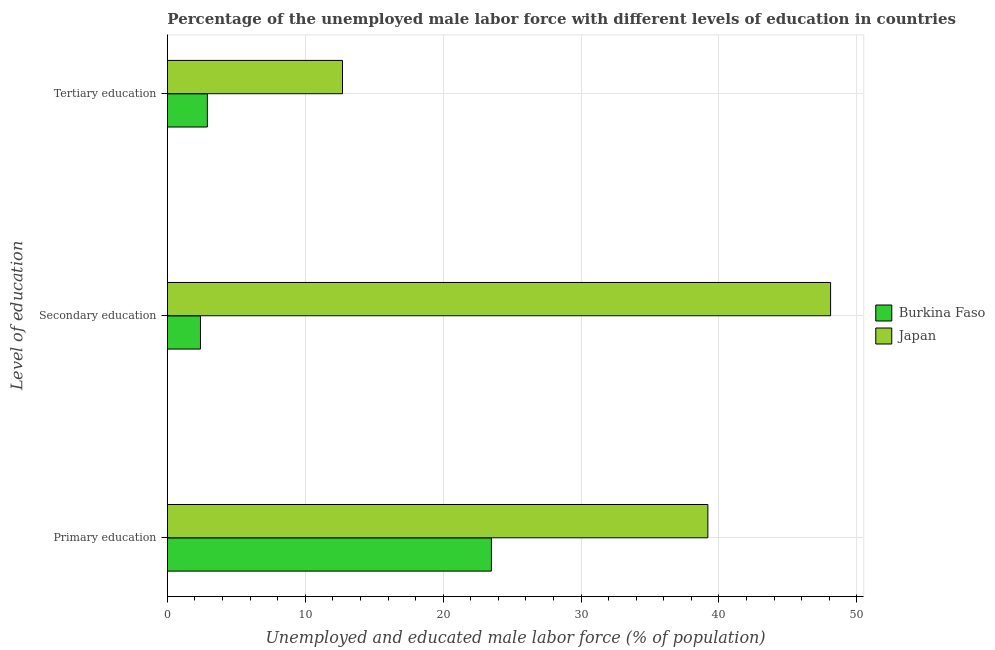Are the number of bars per tick equal to the number of legend labels?
Your answer should be compact. Yes. How many bars are there on the 1st tick from the bottom?
Offer a very short reply. 2. What is the label of the 2nd group of bars from the top?
Offer a terse response. Secondary education. What is the percentage of male labor force who received secondary education in Burkina Faso?
Make the answer very short. 2.4. Across all countries, what is the maximum percentage of male labor force who received primary education?
Offer a terse response. 39.2. Across all countries, what is the minimum percentage of male labor force who received secondary education?
Your response must be concise. 2.4. In which country was the percentage of male labor force who received secondary education maximum?
Give a very brief answer. Japan. In which country was the percentage of male labor force who received tertiary education minimum?
Provide a succinct answer. Burkina Faso. What is the total percentage of male labor force who received primary education in the graph?
Make the answer very short. 62.7. What is the difference between the percentage of male labor force who received primary education in Japan and that in Burkina Faso?
Your answer should be compact. 15.7. What is the difference between the percentage of male labor force who received primary education in Japan and the percentage of male labor force who received tertiary education in Burkina Faso?
Provide a succinct answer. 36.3. What is the average percentage of male labor force who received secondary education per country?
Keep it short and to the point. 25.25. What is the difference between the percentage of male labor force who received tertiary education and percentage of male labor force who received secondary education in Japan?
Your answer should be compact. -35.4. In how many countries, is the percentage of male labor force who received tertiary education greater than 2 %?
Make the answer very short. 2. What is the ratio of the percentage of male labor force who received tertiary education in Burkina Faso to that in Japan?
Offer a very short reply. 0.23. What is the difference between the highest and the second highest percentage of male labor force who received secondary education?
Give a very brief answer. 45.7. What is the difference between the highest and the lowest percentage of male labor force who received secondary education?
Offer a very short reply. 45.7. In how many countries, is the percentage of male labor force who received primary education greater than the average percentage of male labor force who received primary education taken over all countries?
Provide a short and direct response. 1. Is the sum of the percentage of male labor force who received tertiary education in Burkina Faso and Japan greater than the maximum percentage of male labor force who received secondary education across all countries?
Make the answer very short. No. What does the 2nd bar from the top in Primary education represents?
Make the answer very short. Burkina Faso. What does the 1st bar from the bottom in Secondary education represents?
Offer a terse response. Burkina Faso. How many bars are there?
Provide a short and direct response. 6. How many countries are there in the graph?
Your answer should be very brief. 2. What is the difference between two consecutive major ticks on the X-axis?
Your answer should be very brief. 10. Are the values on the major ticks of X-axis written in scientific E-notation?
Offer a very short reply. No. Does the graph contain any zero values?
Provide a short and direct response. No. Does the graph contain grids?
Offer a very short reply. Yes. Where does the legend appear in the graph?
Your answer should be compact. Center right. How are the legend labels stacked?
Your answer should be very brief. Vertical. What is the title of the graph?
Make the answer very short. Percentage of the unemployed male labor force with different levels of education in countries. What is the label or title of the X-axis?
Make the answer very short. Unemployed and educated male labor force (% of population). What is the label or title of the Y-axis?
Offer a terse response. Level of education. What is the Unemployed and educated male labor force (% of population) of Japan in Primary education?
Offer a terse response. 39.2. What is the Unemployed and educated male labor force (% of population) of Burkina Faso in Secondary education?
Give a very brief answer. 2.4. What is the Unemployed and educated male labor force (% of population) in Japan in Secondary education?
Give a very brief answer. 48.1. What is the Unemployed and educated male labor force (% of population) of Burkina Faso in Tertiary education?
Your answer should be compact. 2.9. What is the Unemployed and educated male labor force (% of population) of Japan in Tertiary education?
Provide a succinct answer. 12.7. Across all Level of education, what is the maximum Unemployed and educated male labor force (% of population) in Burkina Faso?
Provide a succinct answer. 23.5. Across all Level of education, what is the maximum Unemployed and educated male labor force (% of population) in Japan?
Give a very brief answer. 48.1. Across all Level of education, what is the minimum Unemployed and educated male labor force (% of population) of Burkina Faso?
Your response must be concise. 2.4. Across all Level of education, what is the minimum Unemployed and educated male labor force (% of population) in Japan?
Offer a terse response. 12.7. What is the total Unemployed and educated male labor force (% of population) in Burkina Faso in the graph?
Your response must be concise. 28.8. What is the difference between the Unemployed and educated male labor force (% of population) of Burkina Faso in Primary education and that in Secondary education?
Provide a succinct answer. 21.1. What is the difference between the Unemployed and educated male labor force (% of population) of Japan in Primary education and that in Secondary education?
Keep it short and to the point. -8.9. What is the difference between the Unemployed and educated male labor force (% of population) of Burkina Faso in Primary education and that in Tertiary education?
Your answer should be very brief. 20.6. What is the difference between the Unemployed and educated male labor force (% of population) in Japan in Primary education and that in Tertiary education?
Offer a terse response. 26.5. What is the difference between the Unemployed and educated male labor force (% of population) in Japan in Secondary education and that in Tertiary education?
Your answer should be very brief. 35.4. What is the difference between the Unemployed and educated male labor force (% of population) of Burkina Faso in Primary education and the Unemployed and educated male labor force (% of population) of Japan in Secondary education?
Give a very brief answer. -24.6. What is the difference between the Unemployed and educated male labor force (% of population) in Burkina Faso in Primary education and the Unemployed and educated male labor force (% of population) in Japan in Tertiary education?
Your answer should be compact. 10.8. What is the difference between the Unemployed and educated male labor force (% of population) of Burkina Faso in Secondary education and the Unemployed and educated male labor force (% of population) of Japan in Tertiary education?
Keep it short and to the point. -10.3. What is the average Unemployed and educated male labor force (% of population) of Japan per Level of education?
Your answer should be very brief. 33.33. What is the difference between the Unemployed and educated male labor force (% of population) of Burkina Faso and Unemployed and educated male labor force (% of population) of Japan in Primary education?
Your answer should be very brief. -15.7. What is the difference between the Unemployed and educated male labor force (% of population) of Burkina Faso and Unemployed and educated male labor force (% of population) of Japan in Secondary education?
Make the answer very short. -45.7. What is the difference between the Unemployed and educated male labor force (% of population) of Burkina Faso and Unemployed and educated male labor force (% of population) of Japan in Tertiary education?
Your response must be concise. -9.8. What is the ratio of the Unemployed and educated male labor force (% of population) of Burkina Faso in Primary education to that in Secondary education?
Your answer should be compact. 9.79. What is the ratio of the Unemployed and educated male labor force (% of population) in Japan in Primary education to that in Secondary education?
Give a very brief answer. 0.81. What is the ratio of the Unemployed and educated male labor force (% of population) of Burkina Faso in Primary education to that in Tertiary education?
Your response must be concise. 8.1. What is the ratio of the Unemployed and educated male labor force (% of population) in Japan in Primary education to that in Tertiary education?
Make the answer very short. 3.09. What is the ratio of the Unemployed and educated male labor force (% of population) of Burkina Faso in Secondary education to that in Tertiary education?
Keep it short and to the point. 0.83. What is the ratio of the Unemployed and educated male labor force (% of population) of Japan in Secondary education to that in Tertiary education?
Ensure brevity in your answer.  3.79. What is the difference between the highest and the second highest Unemployed and educated male labor force (% of population) of Burkina Faso?
Offer a very short reply. 20.6. What is the difference between the highest and the second highest Unemployed and educated male labor force (% of population) of Japan?
Your answer should be compact. 8.9. What is the difference between the highest and the lowest Unemployed and educated male labor force (% of population) in Burkina Faso?
Keep it short and to the point. 21.1. What is the difference between the highest and the lowest Unemployed and educated male labor force (% of population) in Japan?
Ensure brevity in your answer.  35.4. 